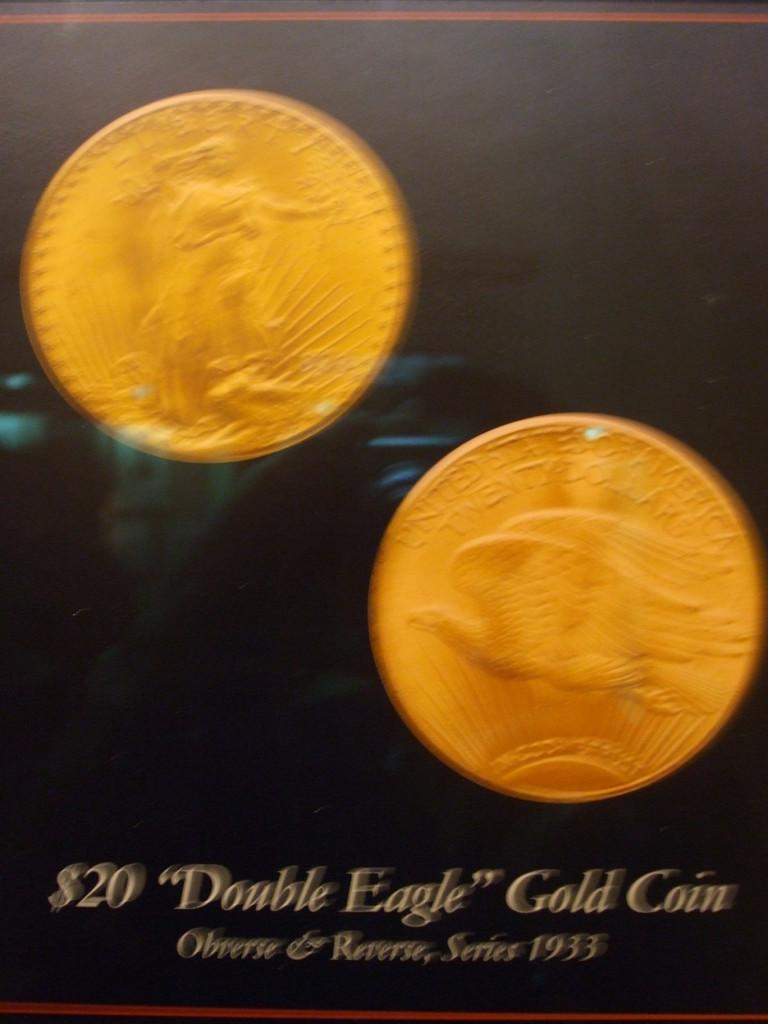Provide a one-sentence caption for the provided image. A pair of 1933 "Double Eagle" gold coins worth $20. 